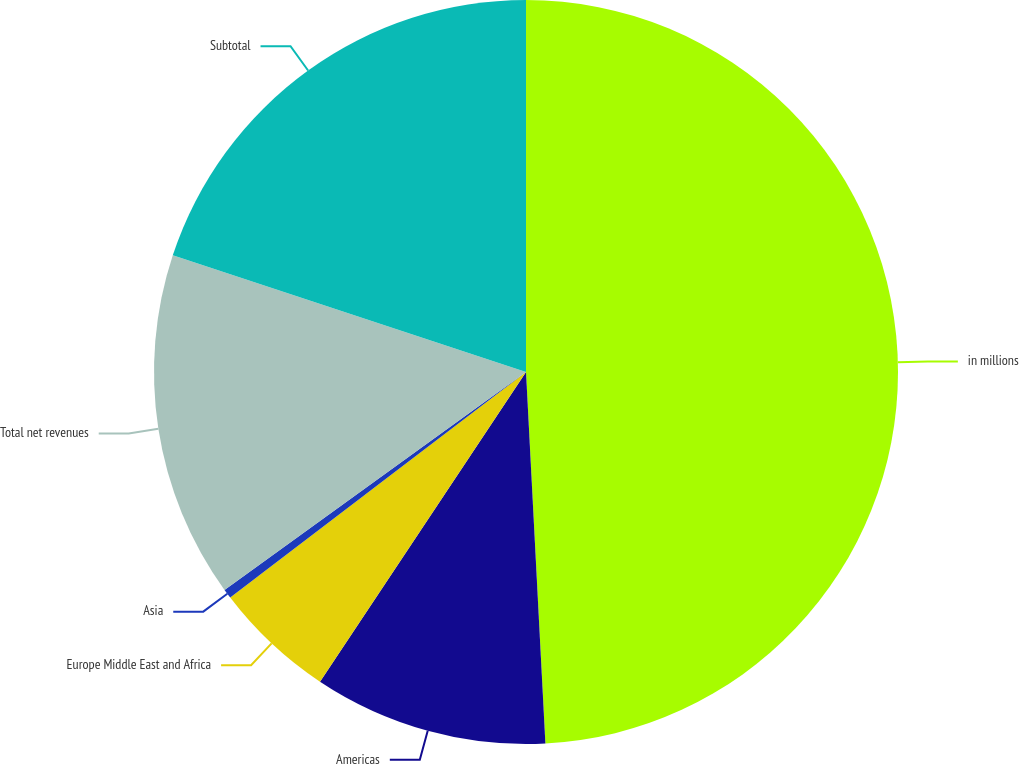Convert chart to OTSL. <chart><loc_0><loc_0><loc_500><loc_500><pie_chart><fcel>in millions<fcel>Americas<fcel>Europe Middle East and Africa<fcel>Asia<fcel>Total net revenues<fcel>Subtotal<nl><fcel>49.17%<fcel>10.17%<fcel>5.29%<fcel>0.41%<fcel>15.04%<fcel>19.92%<nl></chart> 